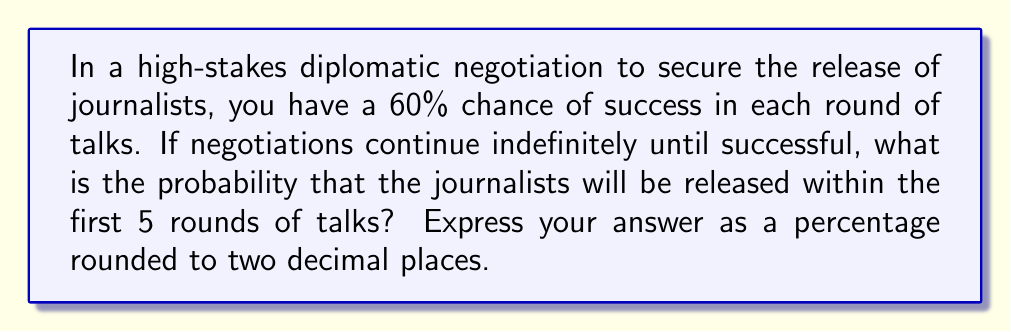Show me your answer to this math problem. Let's approach this step-by-step using a geometric series:

1) The probability of success in each round is 60% or 0.6.

2) The probability of failure in each round is 1 - 0.6 = 0.4.

3) We need to find the probability of success in at least one of the first 5 rounds. This is equivalent to 1 minus the probability of failing all 5 rounds.

4) The probability of failing all 5 rounds is:

   $$(0.4)^5 = 0.01024$$

5) Therefore, the probability of success within the first 5 rounds is:

   $$1 - (0.4)^5 = 1 - 0.01024 = 0.98976$$

6) This can be generalized using the formula for the sum of a geometric series:

   $$S_n = 1 - r^n$$

   Where $r$ is the probability of failure (0.4) and $n$ is the number of rounds (5).

7) Converting to a percentage:

   $$0.98976 \times 100 = 98.976\%$$

8) Rounding to two decimal places:

   $$98.98\%$$
Answer: 98.98% 